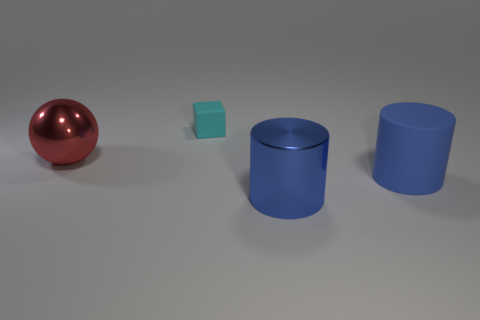What shape is the object that is the same color as the matte cylinder?
Keep it short and to the point. Cylinder. How many large red objects have the same material as the cyan thing?
Make the answer very short. 0. What shape is the big object that is to the right of the red object and behind the blue metal cylinder?
Your answer should be compact. Cylinder. Do the tiny cyan object that is behind the large red shiny thing and the large red object have the same material?
Keep it short and to the point. No. Are there any other things that have the same material as the cyan block?
Offer a very short reply. Yes. There is a metal thing that is the same size as the shiny cylinder; what is its color?
Provide a succinct answer. Red. Is there a big sphere that has the same color as the tiny object?
Offer a very short reply. No. The object that is made of the same material as the small cube is what size?
Make the answer very short. Large. There is another cylinder that is the same color as the large rubber cylinder; what size is it?
Your answer should be compact. Large. How many other objects are there of the same size as the rubber cylinder?
Provide a short and direct response. 2. 